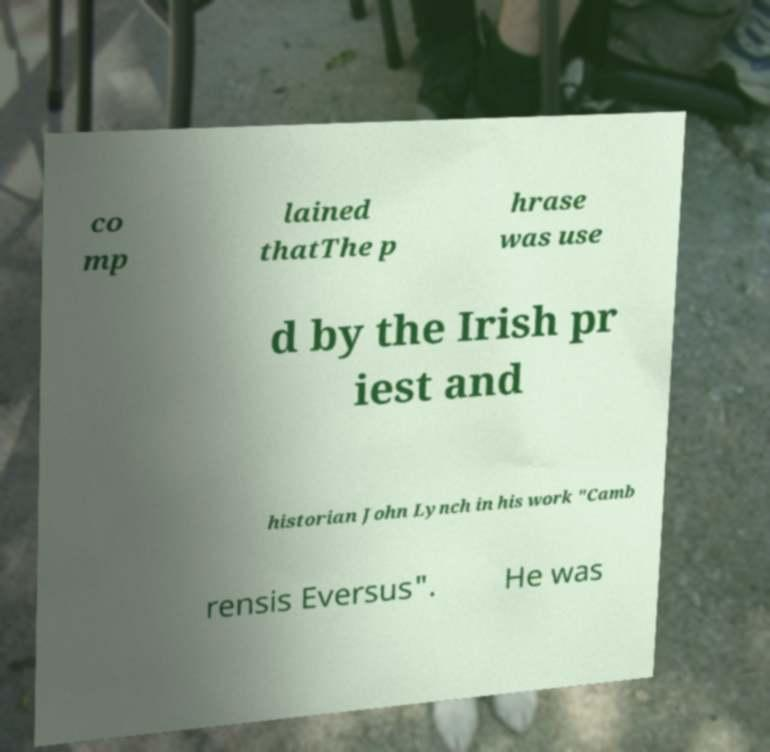Can you read and provide the text displayed in the image?This photo seems to have some interesting text. Can you extract and type it out for me? co mp lained thatThe p hrase was use d by the Irish pr iest and historian John Lynch in his work "Camb rensis Eversus". He was 